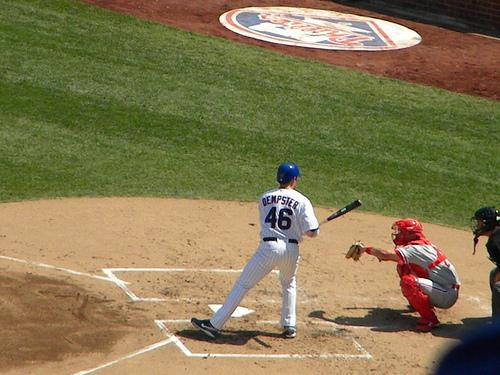What is number 46 waiting for? pitch 